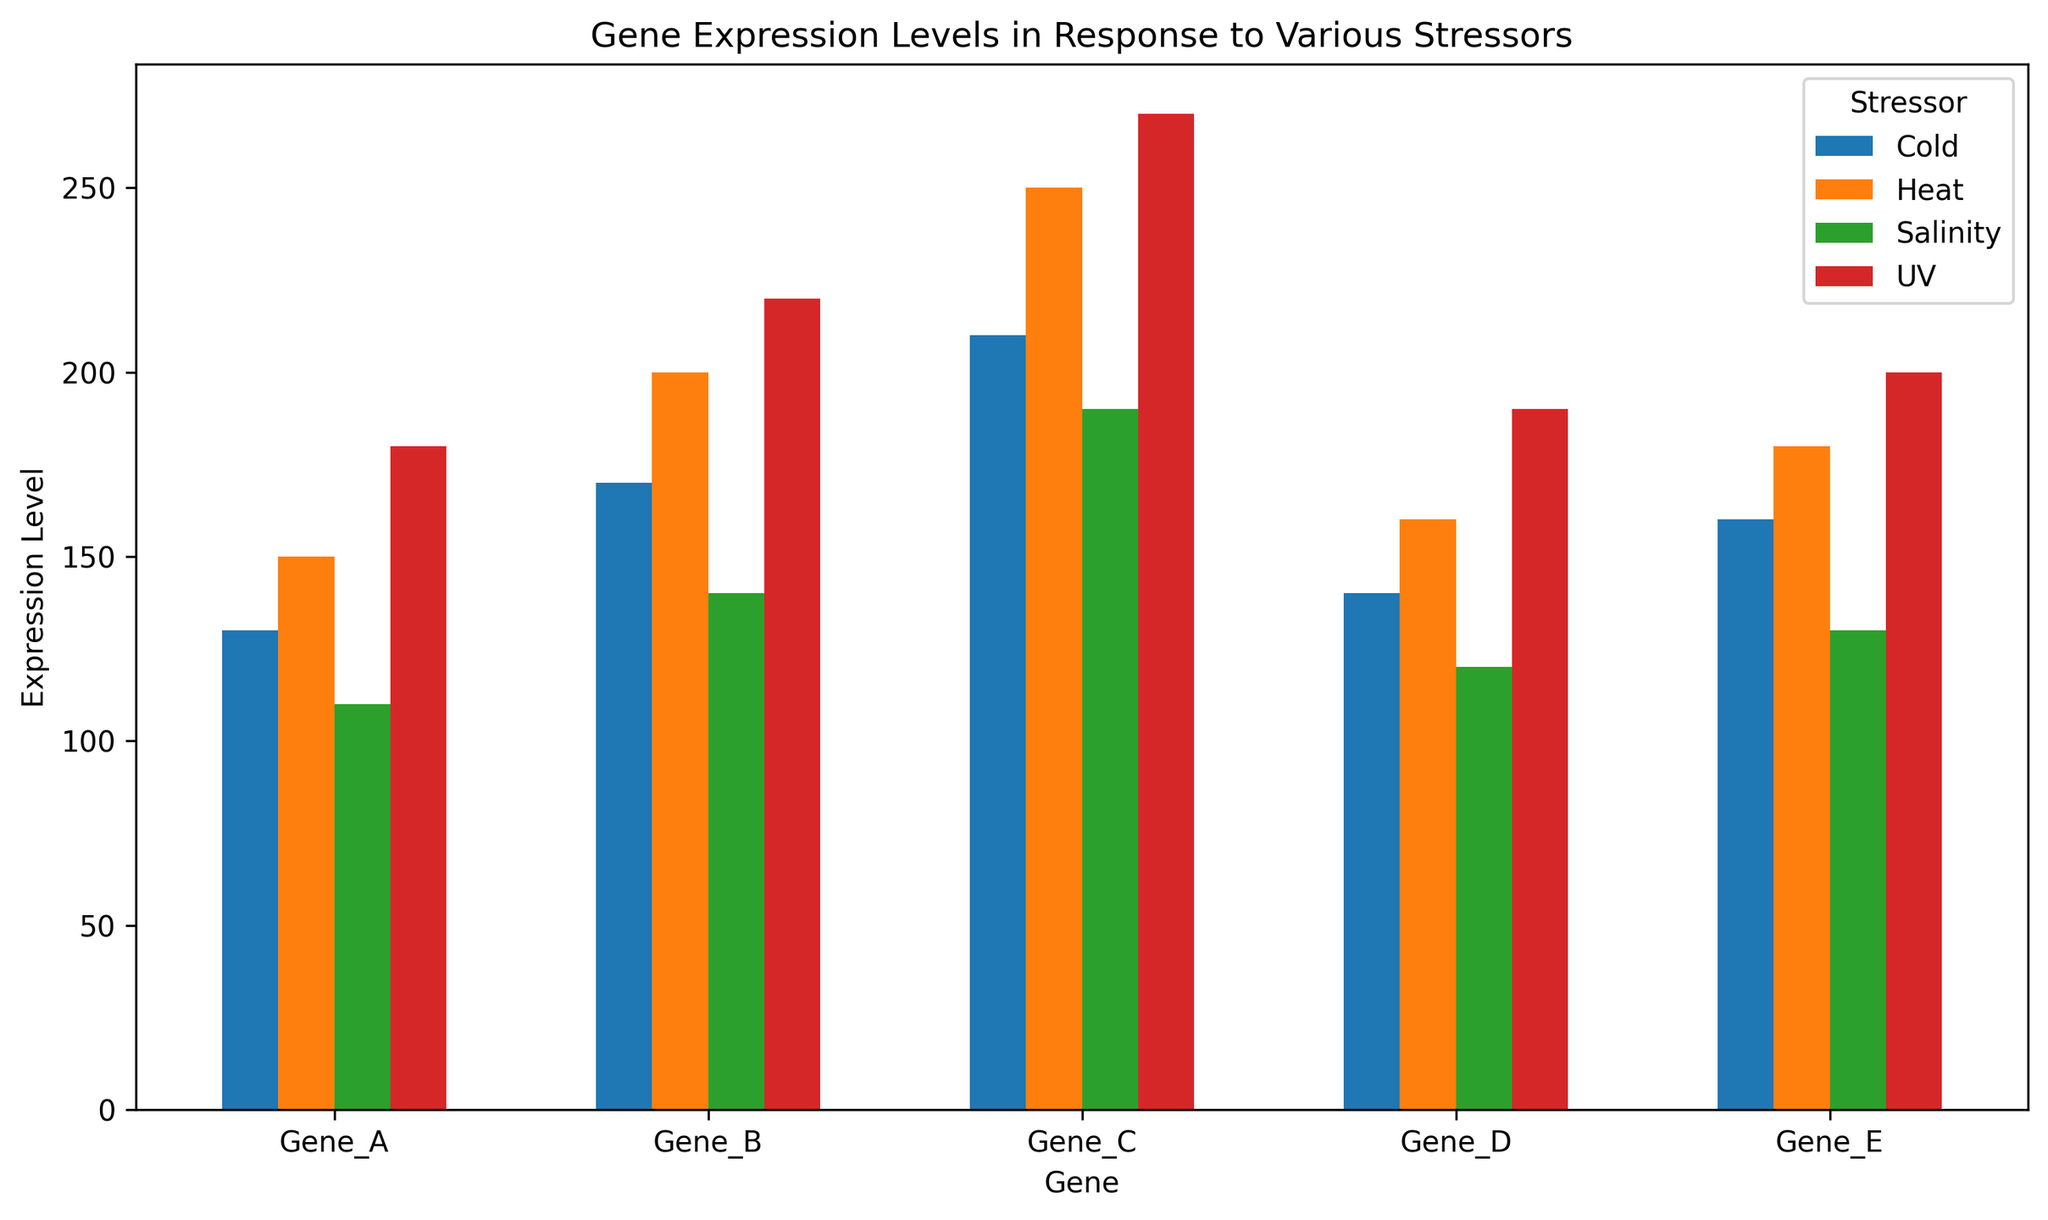Which gene has the highest expression level under UV stress? By looking at the bar heights for UV stress, the highest bar corresponds to Gene C with an expression level of 270.
Answer: Gene C Which stressor leads to the highest expression level for Gene B? For Gene B, compare the bar heights for the different stressors. The highest bar is for UV stress with an expression level of 220.
Answer: UV What is the difference in expression levels of Gene D under Heat and Salinity stress? Gene D shows an expression level of 160 under Heat stress and 120 under Salinity stress. The difference is 160 - 120 = 40.
Answer: 40 Which gene shows the least variation in expression levels across different stressors? By examining the range of bar heights for each gene, Gene A has the least variation, with a minimum expression of 110 and a maximum of 180.
Answer: Gene A How does Gene E's expression level in Cold stress compare to Gene A's expression level in the same condition? The bar height for Gene E under Cold stress is 160, whereas for Gene A under Cold stress, it is 130. Gene E has a higher expression level.
Answer: Gene E has a higher expression level What is the average expression level of Gene C across all stressors? Add the expression levels for Gene C under all stressors [250, 210, 270, 190] and divide by the number of stressors (4). (250 + 210 + 270 + 190) / 4 = 230.
Answer: 230 How does the expression level of Gene A under Heat stress compare to the average expression level of Gene E across all stressors? Gene A under Heat stress has an expression level of 150. The average expression level for Gene E across all stressors [180, 160, 200, 130] is (180 + 160 + 200 + 130) / 4 = 167.5. Gene A's expression under Heat is less than the average expression of Gene E.
Answer: Less Which stressor causes a higher average expression level across all genes: Cold or Salinity? First, calculate the average expression level for Cold [130, 170, 210, 140, 160] = (130 + 170 + 210 + 140 + 160) / 5 = 162. Then, calculate the average for Salinity [110, 140, 190, 120, 130] = (110 + 140 + 190 + 120 + 130) / 5 = 138. Cold stress leads to a higher average expression level.
Answer: Cold Which gene shows the highest variation in expression levels under different stressors? By examining the range of bar heights for each gene, Gene C has the highest variation, with a minimum expression of 190 and a maximum of 270, resulting in a range of 80.
Answer: Gene C What is the sum of expression levels of all genes under UV stress? Sum the values for all genes under UV stress [180, 220, 270, 190, 200]. 180 + 220 + 270 + 190 + 200 = 1060.
Answer: 1060 